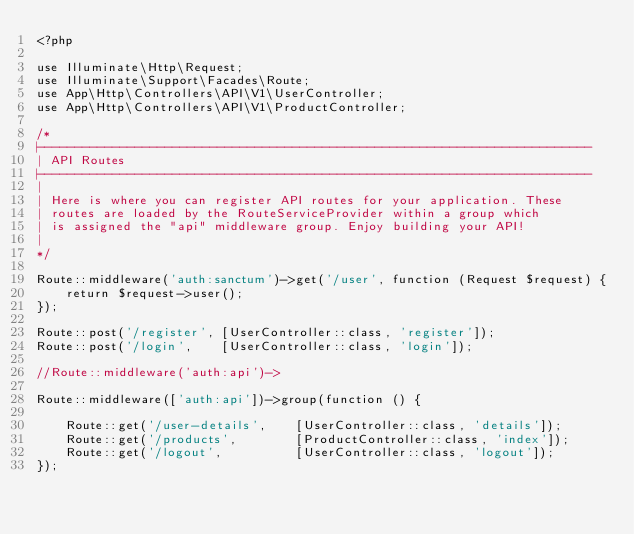<code> <loc_0><loc_0><loc_500><loc_500><_PHP_><?php

use Illuminate\Http\Request;
use Illuminate\Support\Facades\Route;
use App\Http\Controllers\API\V1\UserController;
use App\Http\Controllers\API\V1\ProductController;

/*
|--------------------------------------------------------------------------
| API Routes
|--------------------------------------------------------------------------
|
| Here is where you can register API routes for your application. These
| routes are loaded by the RouteServiceProvider within a group which
| is assigned the "api" middleware group. Enjoy building your API!
|
*/

Route::middleware('auth:sanctum')->get('/user', function (Request $request) {
    return $request->user();
});

Route::post('/register', [UserController::class, 'register']);
Route::post('/login',    [UserController::class, 'login']);

//Route::middleware('auth:api')->

Route::middleware(['auth:api'])->group(function () {

    Route::get('/user-details',    [UserController::class, 'details']);
    Route::get('/products',        [ProductController::class, 'index']);
    Route::get('/logout',          [UserController::class, 'logout']);
});
</code> 